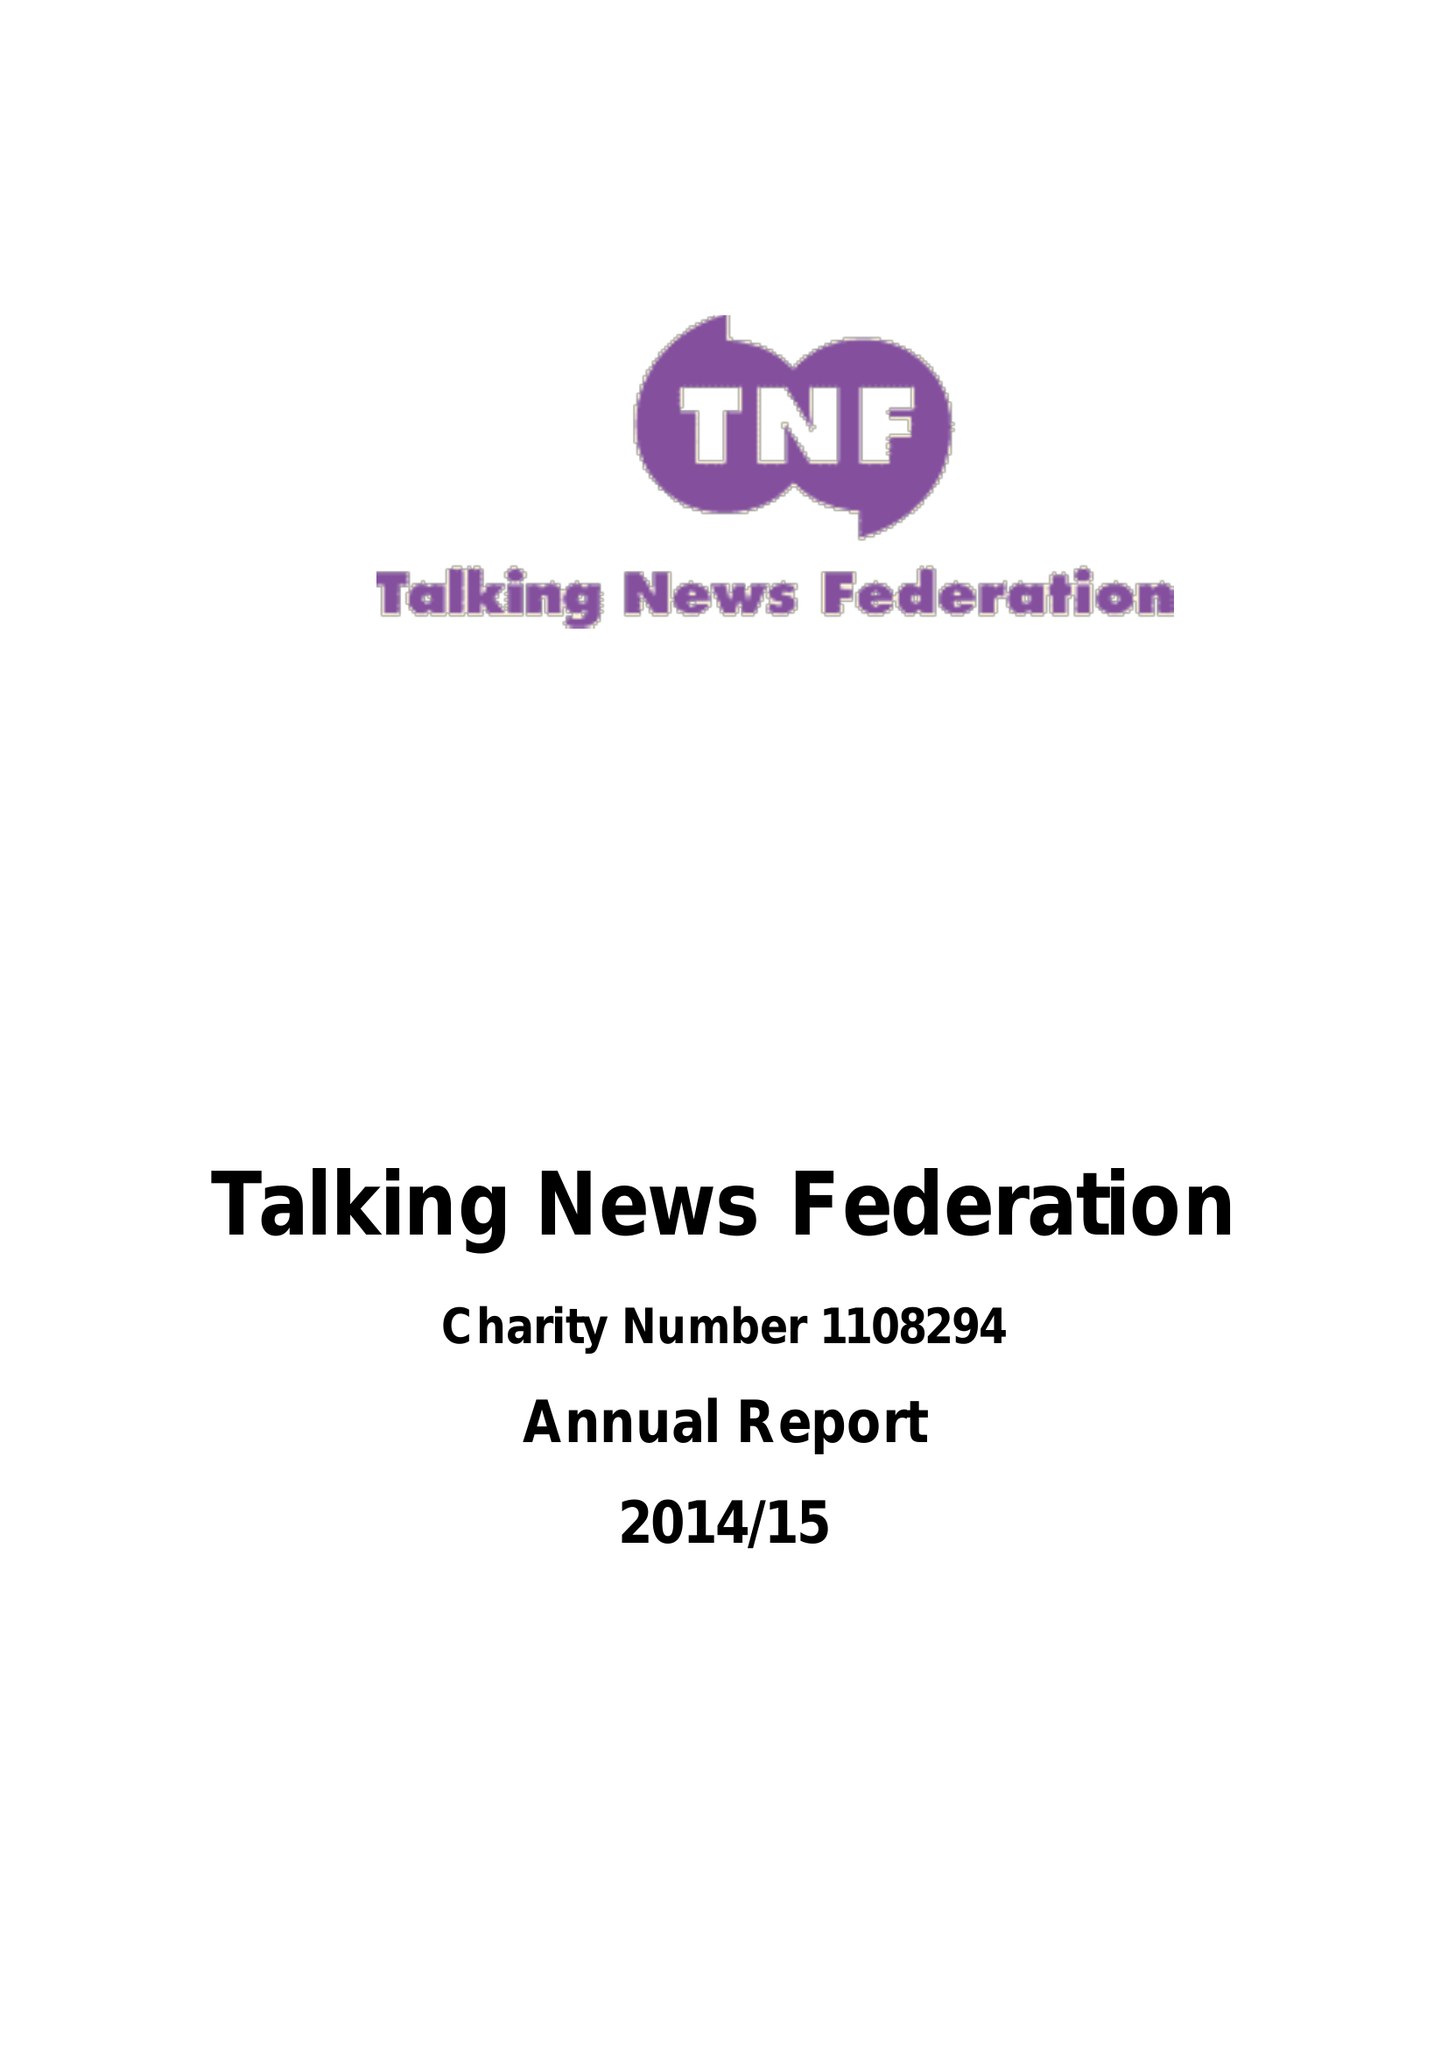What is the value for the spending_annually_in_british_pounds?
Answer the question using a single word or phrase. 30020.98 